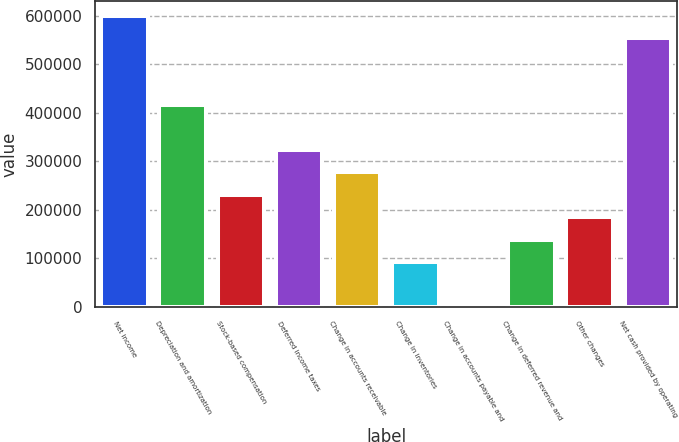Convert chart. <chart><loc_0><loc_0><loc_500><loc_500><bar_chart><fcel>Net income<fcel>Depreciation and amortization<fcel>Stock-based compensation<fcel>Deferred income taxes<fcel>Change in accounts receivable<fcel>Change in inventories<fcel>Change in accounts payable and<fcel>Change in deferred revenue and<fcel>Other changes<fcel>Net cash provided by operating<nl><fcel>599707<fcel>415355<fcel>231003<fcel>323179<fcel>277091<fcel>92739<fcel>563<fcel>138827<fcel>184915<fcel>553619<nl></chart> 